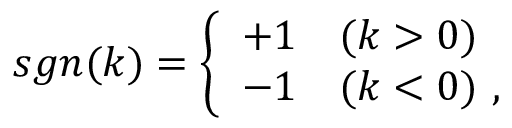Convert formula to latex. <formula><loc_0><loc_0><loc_500><loc_500>s g n ( k ) = \left \{ \begin{array} { l l } { + 1 } & { ( k > 0 ) } \\ { - 1 } & { ( k < 0 ) \, , } \end{array}</formula> 